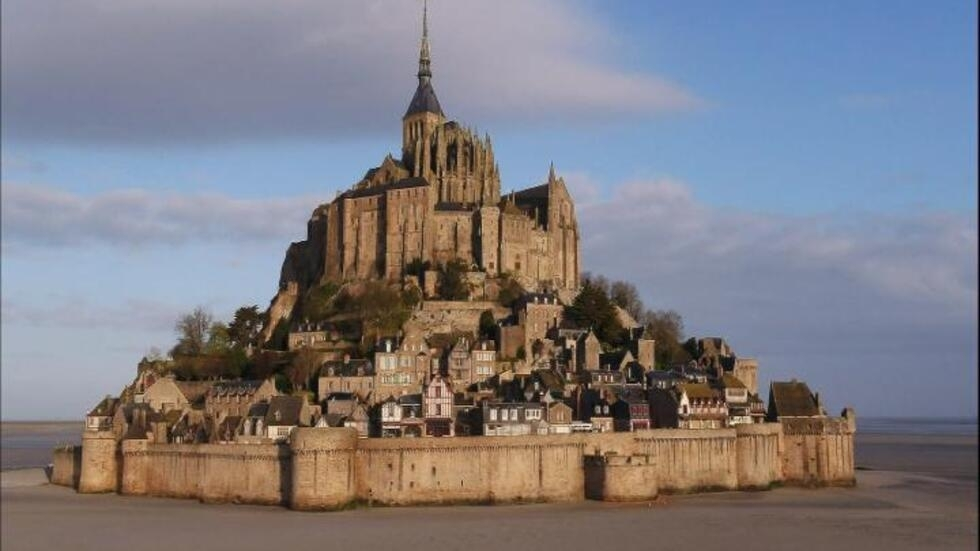Can you describe a day in the life of someone living here centuries ago? A day in the life of a resident of Mont Saint-Michel centuries ago would have been both challenging and fascinating. Imagine waking up to the sound of the sea and the tolling bells of the abbey. The day would begin early, with villagers performing various tasks: fishing in the surrounding waters, tending to livestock, or working in the fields. The abbey's monks would be immersed in their routines of prayer, study, and manuscript writing. Throughout the day, the island would see pilgrims arriving, seeking spiritual solace or healing, bringing a mix of cultures and stories from distant lands. Meals would be simple yet hearty, often shared in communal settings. As the sun sets, the village would slowly quiet down, with firelight flickering from homes and the abbey, casting shadows on the ancient stone walls. Life was undoubtedly tough but also rich with community, faith, and the ever-present mystery of the tides. How would it feel to stand at the top of the abbey spire? Standing at the top of the abbey spire, one would feel an overwhelming sense of awe and accomplishment. The panoramic view offers a breathtaking sweep of the island, the quaint village below, and the vast expanse of the surrounding bay. On a clear day, the horizon seems endless, merging sky and sea in a seamless blend of blue. The wind would be brisk and refreshing, adding to the feeling of being on top of the world. It's a place where the physical effort to climb such heights is rewarded with a moment of profound reflection and a deeper connection to the historical and spiritual significance of Mont Saint-Michel. 